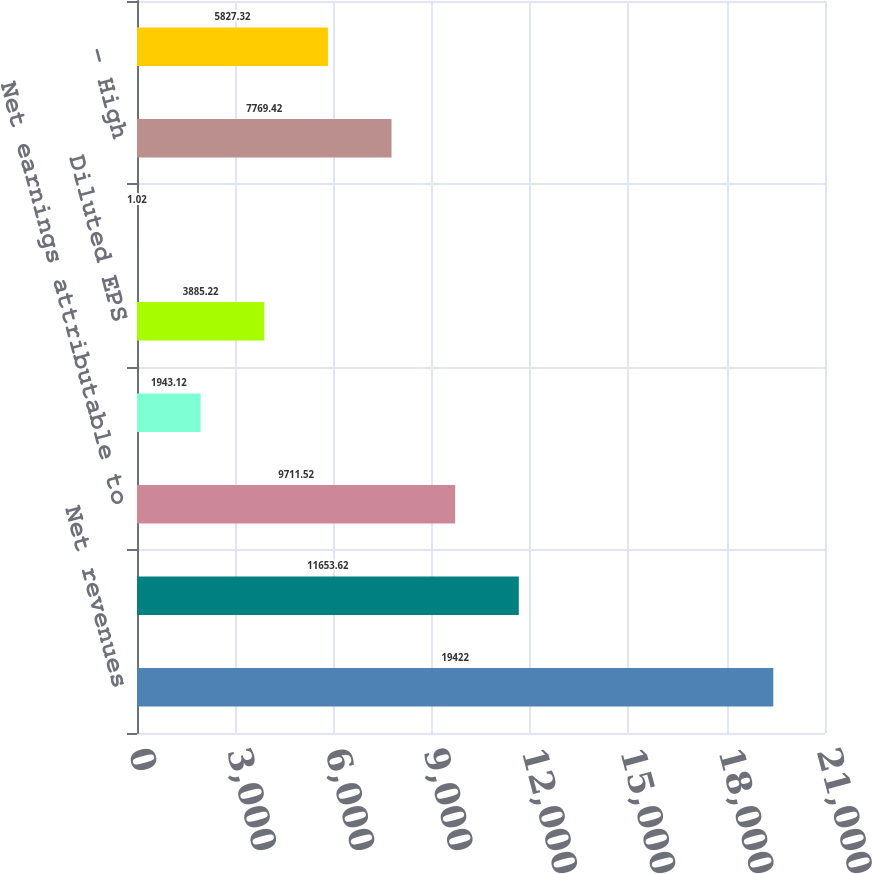Convert chart to OTSL. <chart><loc_0><loc_0><loc_500><loc_500><bar_chart><fcel>Net revenues<fcel>Gross profit<fcel>Net earnings attributable to<fcel>Basic EPS<fcel>Diluted EPS<fcel>Dividends declared<fcel>- High<fcel>- Low<nl><fcel>19422<fcel>11653.6<fcel>9711.52<fcel>1943.12<fcel>3885.22<fcel>1.02<fcel>7769.42<fcel>5827.32<nl></chart> 